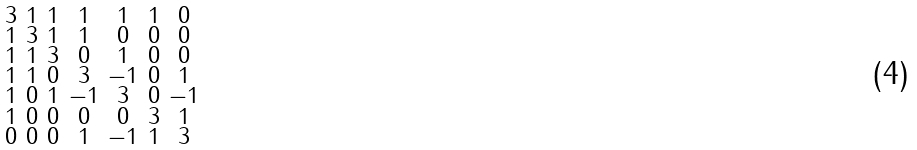<formula> <loc_0><loc_0><loc_500><loc_500>\begin{smallmatrix} 3 & 1 & 1 & 1 & 1 & 1 & 0 \\ 1 & 3 & 1 & 1 & 0 & 0 & 0 \\ 1 & 1 & 3 & 0 & 1 & 0 & 0 \\ 1 & 1 & 0 & 3 & - 1 & 0 & 1 \\ 1 & 0 & 1 & - 1 & 3 & 0 & - 1 \\ 1 & 0 & 0 & 0 & 0 & 3 & 1 \\ 0 & 0 & 0 & 1 & - 1 & 1 & 3 \end{smallmatrix}</formula> 